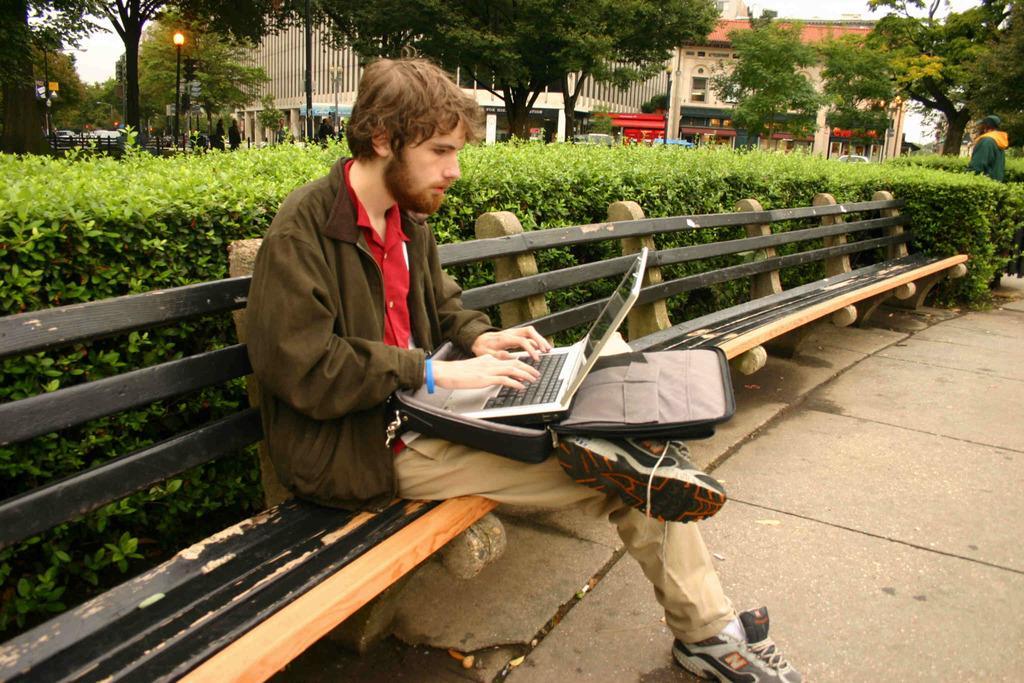Please provide a concise description of this image. In this image there is a man sitting on a bench, on his lap there is a laptop, in the background there are plants trees and building. 